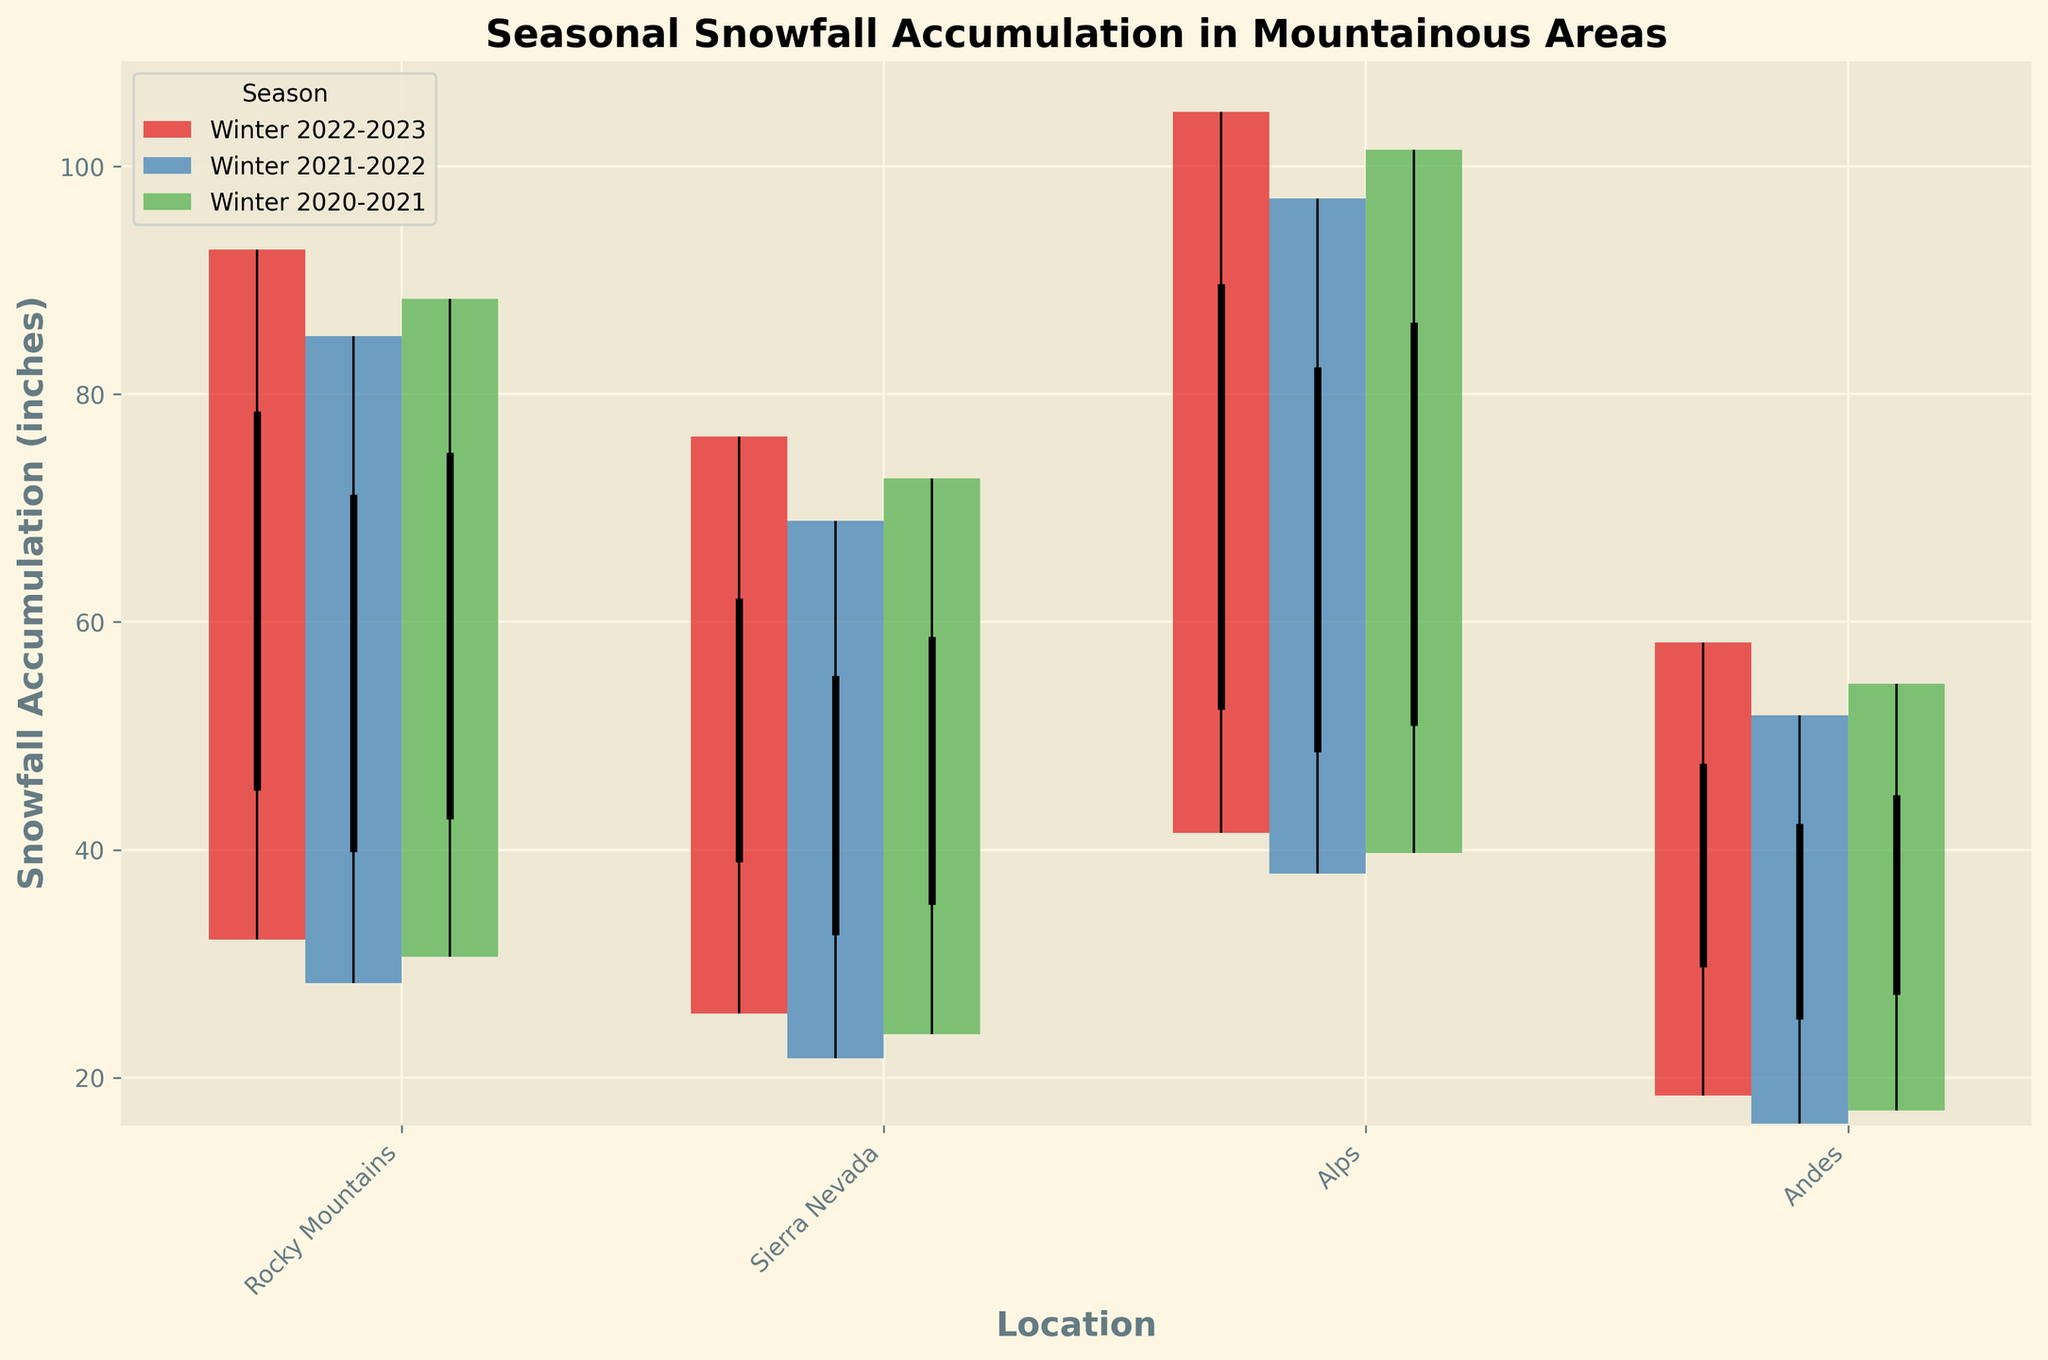What's the title of the chart? The title is usually found at the top of the chart, in a larger and bold font. In this case, it reads "Seasonal Snowfall Accumulation in Mountainous Areas".
Answer: Seasonal Snowfall Accumulation in Mountainous Areas Which location had the highest snowfall in Winter 2022-2023? Look for the season Winter 2022-2023 and identify which bar has the highest "High" value within that season. The Alps had the highest snow accumulation at 104.8 inches.
Answer: Alps What is the range of snowfall in the Andes during Winter 2021-2022? The range can be calculated by subtracting the "Low" value from the "High" value. For Winter 2021-2022 in the Andes, it’s 51.8 - 15.9.
Answer: 35.9 inches How did snowfall close in the Rocky Mountains comparing Winter 2022-2023 to Winter 2021-2022? Check the "Close" values for the Rocky Mountains for both winters. For Winter 2022-2023, it’s 78.5 inches and for Winter 2021-2022, it’s 71.2 inches. The difference is 78.5 - 71.2.
Answer: 7.3 inches higher Between Sierra Nevada and Andes, which location had more consistent snowfall in Winter 2020-2021? Consistency can be indicated by a smaller range, calculated by subtracting "Low" from "High". For Winter 2020-2021, Sierra Nevada had a range of 48.8 (72.6-23.8) and Andes had 37.5 (54.6-17.1). Andes is more consistent.
Answer: Andes What was the average snowfall "Close" value in the Alps over the three winters? Calculate the average by summing the "Close" values for each winter (89.7+82.4+86.3) and dividing by 3.
Answer: 86.13 inches Which location showed the largest increase in "Open" snowfall from Winter 2021-2022 to Winter 2022-2023? Calculate the difference in "Open" values for all locations between the two winters and identify the largest. Rocky Mountains: 45.2 - 39.8 = 5.4 inches. Sierra Nevada: 38.9 - 32.5 = 6.4 inches. Alps: 52.3 - 48.6 = 3.7 inches. Andes: 29.7 - 25.1 = 4.6 inches. The largest increase is in Sierra Nevada.
Answer: Sierra Nevada Compare the highest snowfall recorded (High value) across all locations in Winter 2020-2021. Which location experienced the highest peak? Compare the "High" values for all locations in Winter 2020-2021. Alps had the highest at 101.5 inches, compared to Rocky Mountains (88.4), Sierra Nevada (72.6), and Andes (54.6).
Answer: Alps How many different seasons are represented in the chart? Count the unique titles listed in the legend or along the x-axis labels that denote seasons. There are three (Winter 2022-2023, Winter 2021-2022, Winter 2020-2021).
Answer: Three In which winter was the lowest snowfall recorded in the Rockies? Look for the lowest "Low" value in the Rocky Mountains across the three seasons. It is 28.3 inches in Winter 2021-2022.
Answer: Winter 2021-2022 Which location had the smallest increase in "Close" snowfall from Winter 2020-2021 to Winter 2021-2022? Calculate the difference in "Close" values for all locations between the two winters and identify the smallest increase or decrease. Rocky Mountains: 71.2 - 74.9 = -3.7 inches. Sierra Nevada: 55.3 - 58.7 = -3.4 inches. Alps: 82.4 - 86.3 = -3.9 inches. Andes: 42.3 - 44.8 = -2.5 inches. The smallest increase is actually a decrease in Andes.
Answer: Andes 